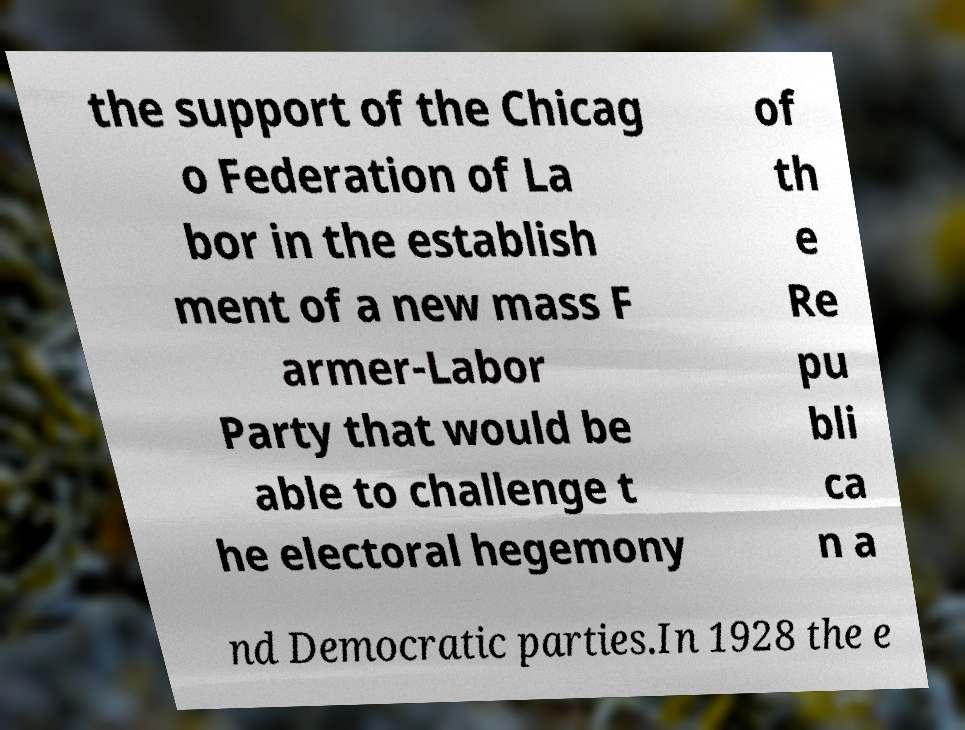For documentation purposes, I need the text within this image transcribed. Could you provide that? the support of the Chicag o Federation of La bor in the establish ment of a new mass F armer-Labor Party that would be able to challenge t he electoral hegemony of th e Re pu bli ca n a nd Democratic parties.In 1928 the e 